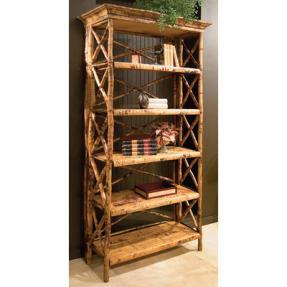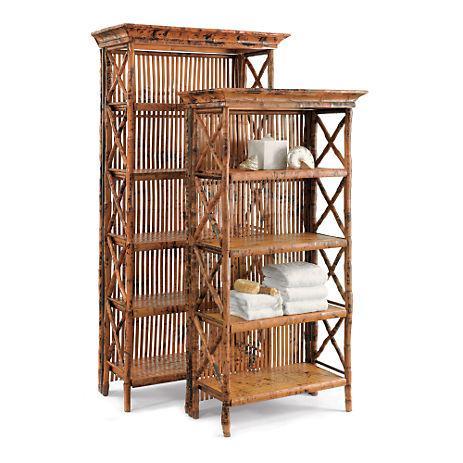The first image is the image on the left, the second image is the image on the right. Assess this claim about the two images: "Left image shows a blond 'traditional' wood shelf unit, and right image shows a rattan shelf unit.". Correct or not? Answer yes or no. No. The first image is the image on the left, the second image is the image on the right. For the images shown, is this caption "Two shelves are the same overall shape and have the same number of shelves, but one is made of bamboo while the other is finished wood." true? Answer yes or no. No. 